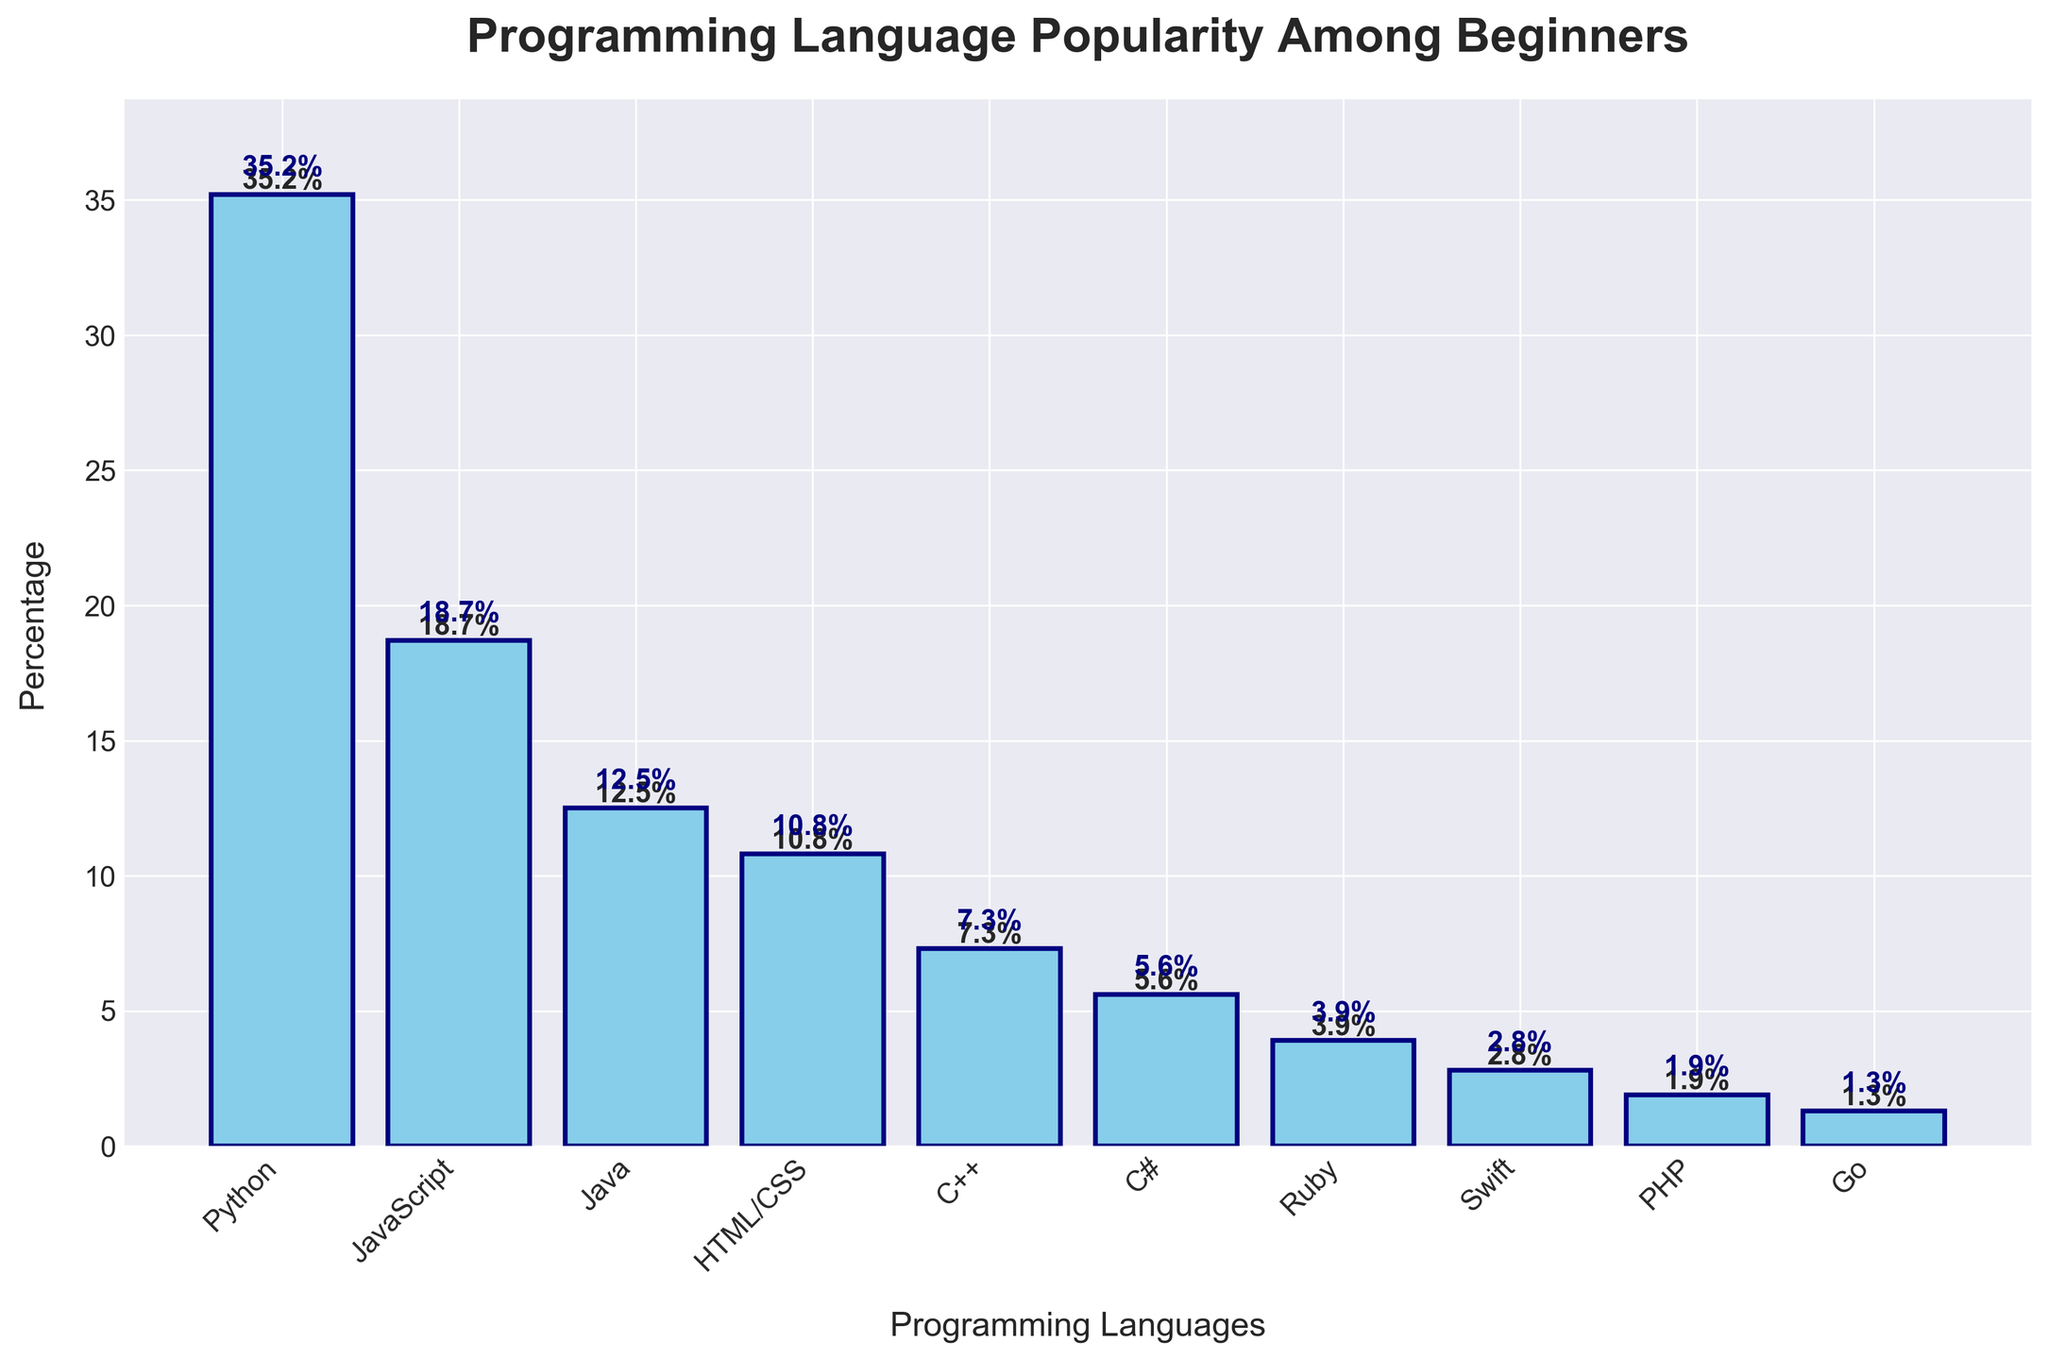What is the most popular programming language among beginners according to the figure? The bar for Python has the highest value at 35.2%, which is higher than any other language. Thus, Python is the most popular.
Answer: Python Which language has a higher percentage of beginners, JavaScript or Java? By examining the heights of the bars, JavaScript has a percentage of 18.7% while Java has 12.5%. Therefore, JavaScript has a higher percentage of beginners.
Answer: JavaScript What is the combined percentage of beginners for HTML/CSS and C++? The percentage for HTML/CSS is 10.8% and for C++ is 7.3%. Adding them together: 10.8% + 7.3% = 18.1%.
Answer: 18.1 How many languages have a percentage of beginners less than 5% according to the figure? The languages with percentages less than 5% are Ruby (3.9%), Swift (2.8%), PHP (1.9%), and Go (1.3%). There are 4 such languages.
Answer: 4 Which language is more popular, Swift or Ruby, and by how much? Ruby has a percentage of 3.9% while Swift has 2.8%. The difference in popularity is 3.9% - 2.8% = 1.1%. Therefore, Ruby is more popular by 1.1%.
Answer: Ruby by 1.1% What is the percentage difference between the most and least popular languages? The most popular language, Python, has 35.2%, and the least popular language, Go, has 1.3%. The difference is 35.2% - 1.3% = 33.9%.
Answer: 33.9% Which language is exactly in the middle in terms of popularity among those listed? There are 10 languages listed. Sorting them by percentage: Python, JavaScript, Java, HTML/CSS, C++, C#, Ruby, Swift, PHP, and Go. The middle one (5th and 6th) are C++ and C#. The middle value is C++ (listed slightly before C# in the data order).
Answer: C++ Is Java more popular than C# according to the figure, and by what percentage? Java has a percentage of 12.5%, while C# has 5.6%. The difference is 12.5% - 5.6% = 6.9%. Therefore, Java is more popular by 6.9%.
Answer: Yes, by 6.9% What is the average percentage of beginners for the top three programming languages? The top three languages are Python (35.2%), JavaScript (18.7%), and Java (12.5%). The average is calculated by (35.2 + 18.7 + 12.5) / 3 = 66.4 / 3 = 22.13%.
Answer: 22.13 